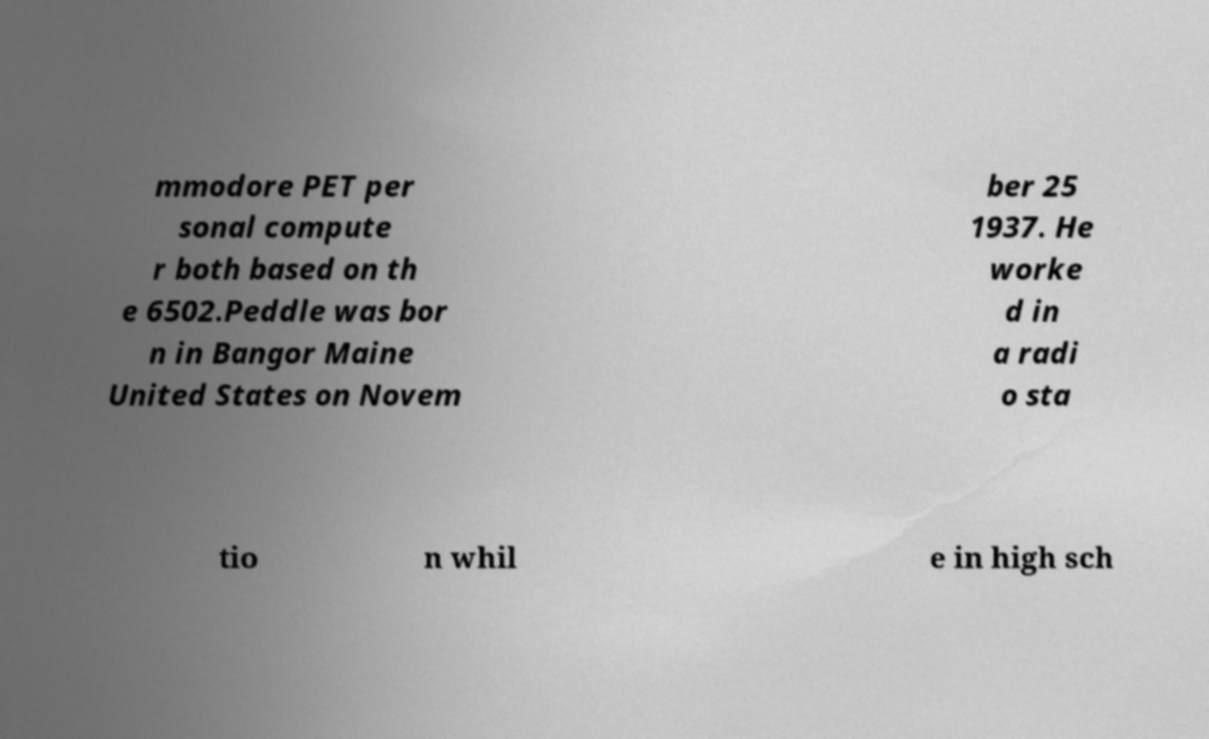Can you accurately transcribe the text from the provided image for me? mmodore PET per sonal compute r both based on th e 6502.Peddle was bor n in Bangor Maine United States on Novem ber 25 1937. He worke d in a radi o sta tio n whil e in high sch 